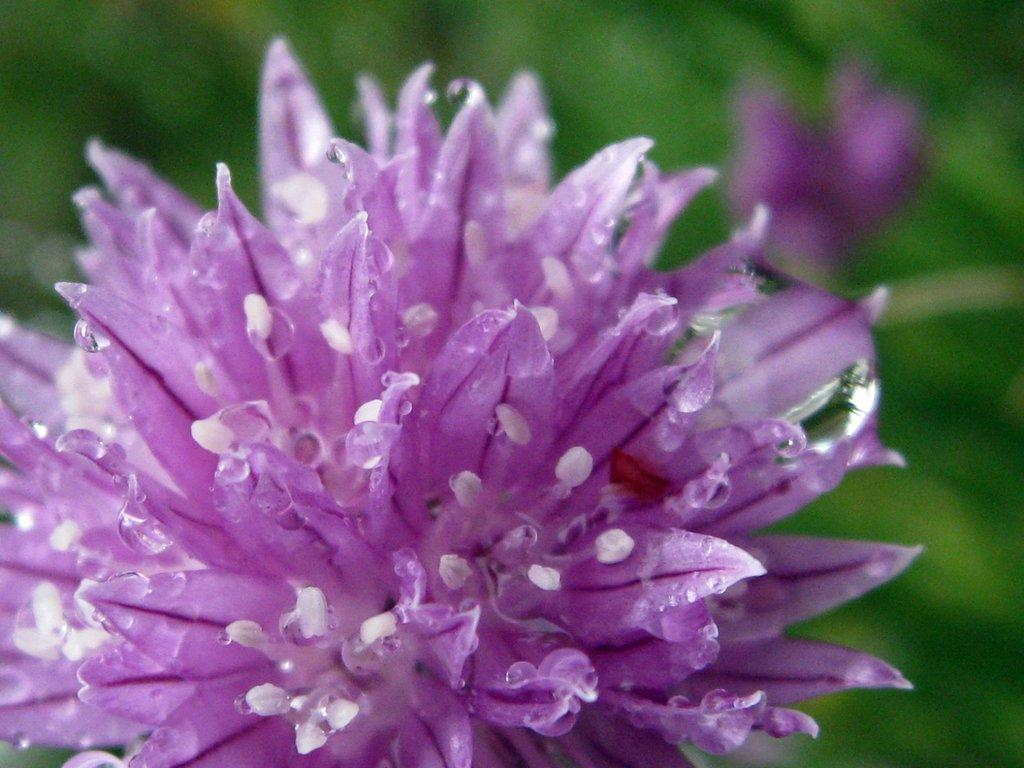What is the main subject of the image? There is a flower in the image. Can you describe the background of the image? The background of the image is blue and green. What type of substance is being transported in the basket in the image? There is no basket present in the image, and therefore no substance being transported. What type of town is visible in the background of the image? There is no town visible in the image; the background consists of blue and green colors. 